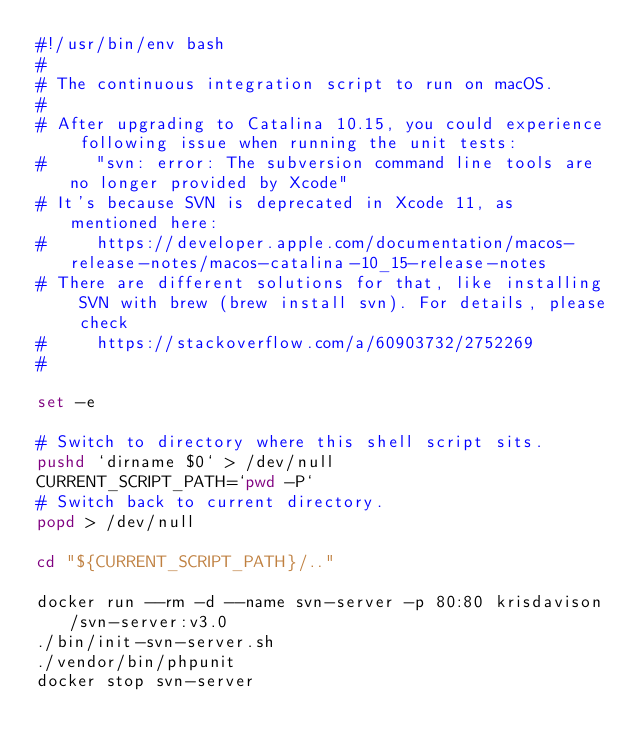Convert code to text. <code><loc_0><loc_0><loc_500><loc_500><_Bash_>#!/usr/bin/env bash
#
# The continuous integration script to run on macOS.
#
# After upgrading to Catalina 10.15, you could experience following issue when running the unit tests:
#     "svn: error: The subversion command line tools are no longer provided by Xcode"
# It's because SVN is deprecated in Xcode 11, as mentioned here:
#     https://developer.apple.com/documentation/macos-release-notes/macos-catalina-10_15-release-notes
# There are different solutions for that, like installing SVN with brew (brew install svn). For details, please check
#     https://stackoverflow.com/a/60903732/2752269
#

set -e

# Switch to directory where this shell script sits.
pushd `dirname $0` > /dev/null
CURRENT_SCRIPT_PATH=`pwd -P`
# Switch back to current directory.
popd > /dev/null

cd "${CURRENT_SCRIPT_PATH}/.."

docker run --rm -d --name svn-server -p 80:80 krisdavison/svn-server:v3.0
./bin/init-svn-server.sh
./vendor/bin/phpunit
docker stop svn-server
</code> 